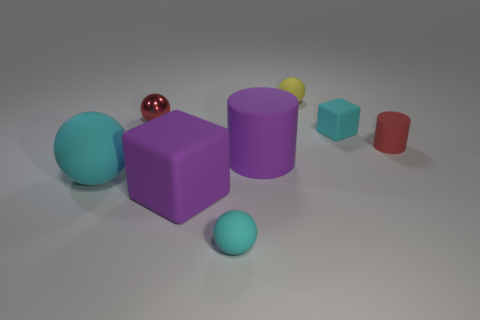What is the material of the tiny red object left of the red object right of the small cyan matte ball?
Your answer should be compact. Metal. How many other objects are the same material as the tiny yellow object?
Give a very brief answer. 6. There is a yellow sphere that is the same size as the red ball; what is it made of?
Give a very brief answer. Rubber. Is the number of yellow spheres that are to the left of the tiny cyan sphere greater than the number of yellow rubber objects to the left of the shiny sphere?
Offer a very short reply. No. Are there any yellow things of the same shape as the big cyan rubber thing?
Provide a succinct answer. Yes. There is a yellow rubber object that is the same size as the red sphere; what is its shape?
Offer a terse response. Sphere. There is a purple object that is behind the large rubber ball; what shape is it?
Make the answer very short. Cylinder. Are there fewer red rubber things in front of the tiny red cylinder than small shiny things behind the shiny thing?
Make the answer very short. No. Do the purple block and the rubber sphere that is on the left side of the small cyan rubber ball have the same size?
Ensure brevity in your answer.  Yes. How many purple cylinders are the same size as the red rubber cylinder?
Offer a very short reply. 0. 